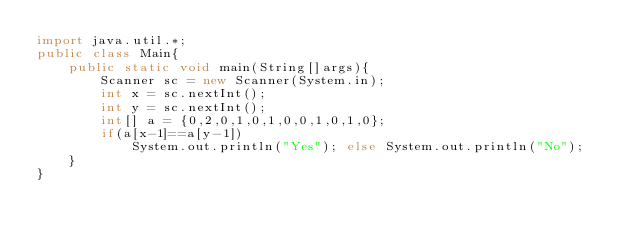Convert code to text. <code><loc_0><loc_0><loc_500><loc_500><_Java_>import java.util.*;
public class Main{
    public static void main(String[]args){
        Scanner sc = new Scanner(System.in);
        int x = sc.nextInt();
        int y = sc.nextInt();
        int[] a = {0,2,0,1,0,1,0,0,1,0,1,0};
        if(a[x-1]==a[y-1])
            System.out.println("Yes"); else System.out.println("No");
    }
}</code> 